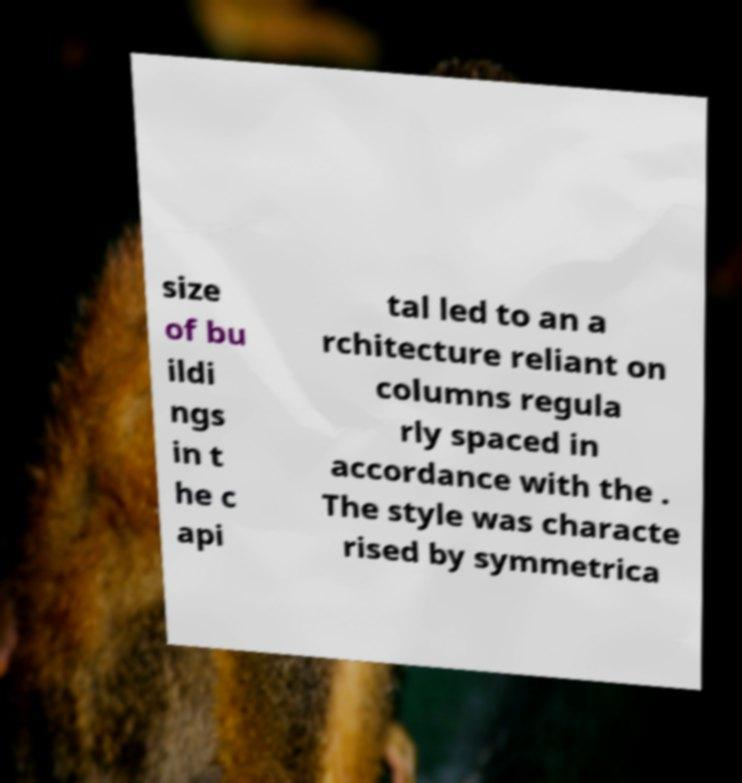Can you accurately transcribe the text from the provided image for me? size of bu ildi ngs in t he c api tal led to an a rchitecture reliant on columns regula rly spaced in accordance with the . The style was characte rised by symmetrica 